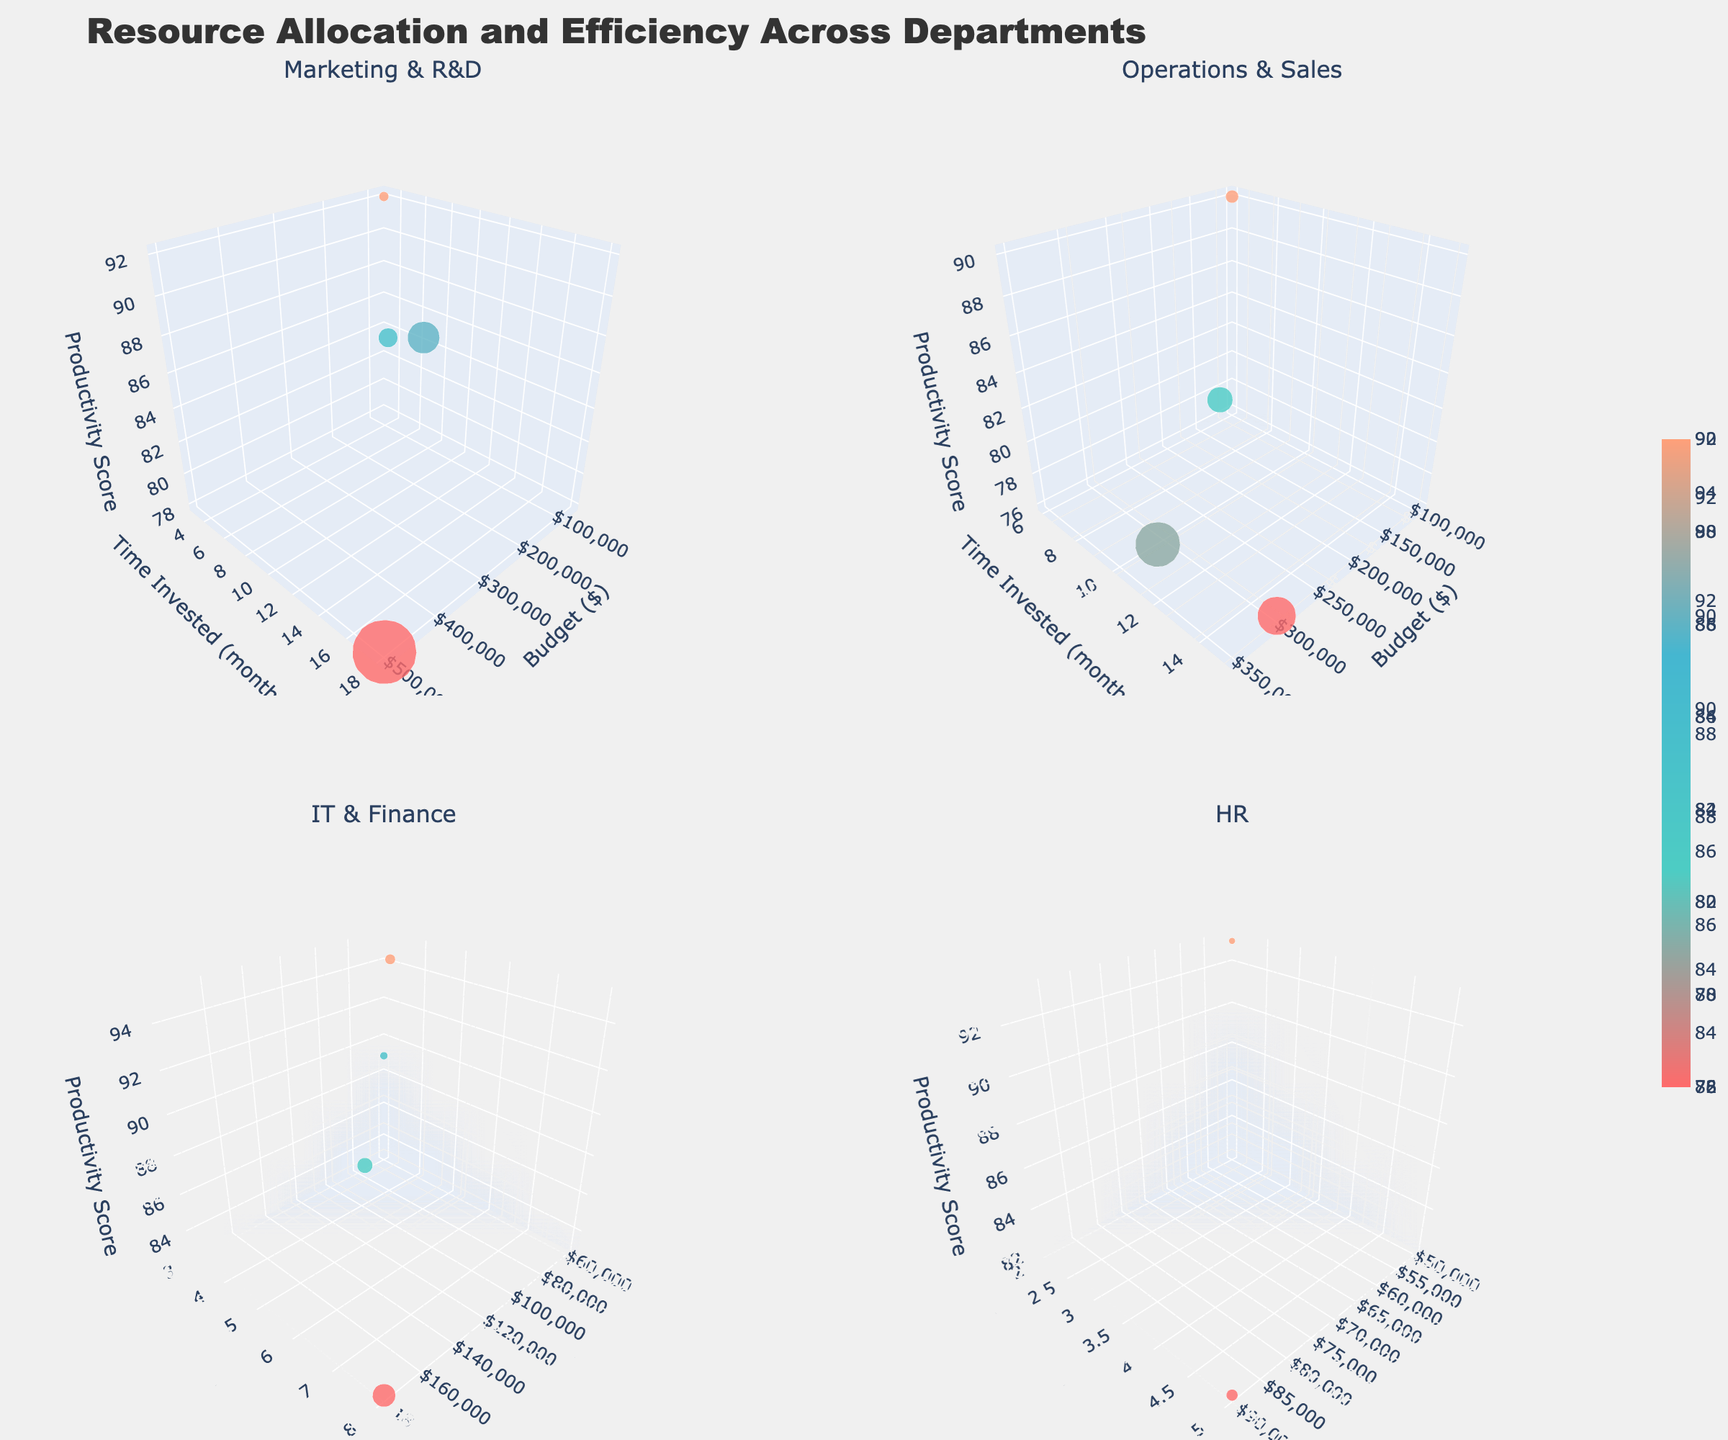What are the departments compared under the subplot titled "Marketing & R&D"? The subplot titles indicate which departments are compared. For "Marketing & R&D," it is clear from the name that it includes the Marketing and R&D departments.
Answer: Marketing, R&D How many projects fall under the "Operations & Sales" subplot? By checking the subplot titled "Operations & Sales" and counting the number of data points, we can determine the number of projects. The data points represent projects.
Answer: 4 Which project in the subplot "HR" has the highest productivity score? Look at the "HR" subplot and identify the data point that is highest on the productivity score (z-axis). Each data point corresponds to a project whose name can be seen by hovering over it.
Answer: Employee Wellness Program What's the total budget allocated for the "Marketing" department? Sum the budgets of all Marketing projects. Marketing has two projects with budgets of 150000 and 75000, respectively. So, 150000 + 75000 = 225000.
Answer: 225000 Which project in the "IT & Finance" subplot has allocated the least budget? In the "IT & Finance" subplot, locate the data point that is furthest left on the budget (x-axis). By hovering or the placement, identify the project.
Answer: Investor Relations Platform What's the difference in productivity scores between the "Supply Chain Optimization" and the "Global Market Entry" projects? Locate both projects in the "Operations & Sales" subplot. Note their productivity scores. Supply Chain Optimization has a score of 81, and Global Market Entry has a score of 79. The difference is 81 - 79 = 2.
Answer: 2 Which department has the highest time invested for a project within the subplot "Marketing & R&D"? In the "Marketing & R&D" subplot, identify the project with the highest y-value (time invested). This corresponds to the department of R&D.
Answer: R&D What is the average productivity score for the "Finance" department? Compute the average productivity score of the Finance department projects. The projects are Cost Reduction Strategy (95) and Investor Relations Platform (89). The average is (95 + 89)/2 = 92.
Answer: 92 Does the "Automation Initiative" project in Operations have a higher or lower productivity score compared to the "Cybersecurity Upgrade" project in IT? Compare the z-values (productivity scores) for "Automation Initiative" in the "Operations & Sales" subplot and "Cybersecurity Upgrade" in the "IT & Finance" subplot. Automation Initiative has a score of 76, and Cybersecurity Upgrade has 87.
Answer: Lower What is the median time invested in "R&D" projects? To find the median time invested, list all the time invested values for R&D: 18 and 12. The median of these two values is 15.
Answer: 15 